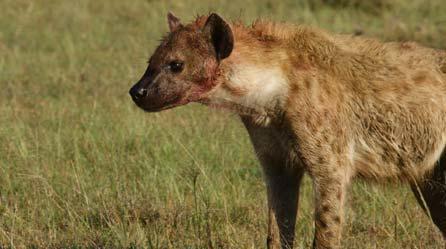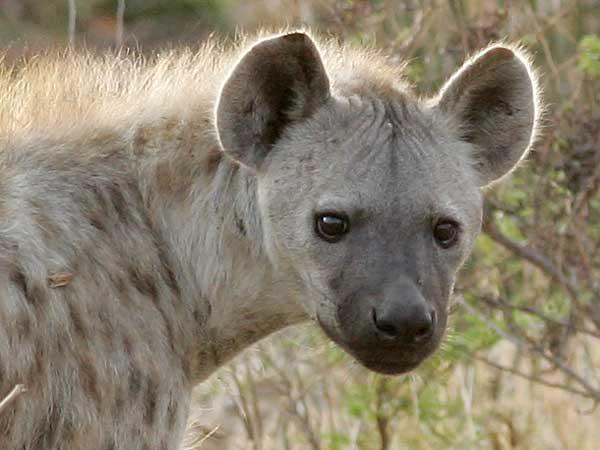The first image is the image on the left, the second image is the image on the right. Given the left and right images, does the statement "The animal in the image on the left is facing the camera" hold true? Answer yes or no. No. 